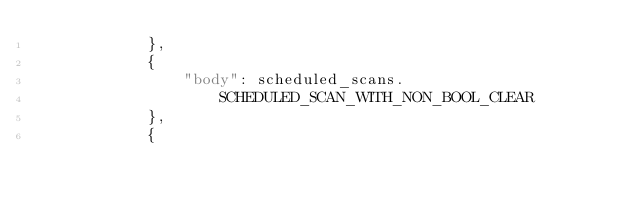<code> <loc_0><loc_0><loc_500><loc_500><_Python_>            },
            {
                "body": scheduled_scans.
                    SCHEDULED_SCAN_WITH_NON_BOOL_CLEAR
            },
            {</code> 